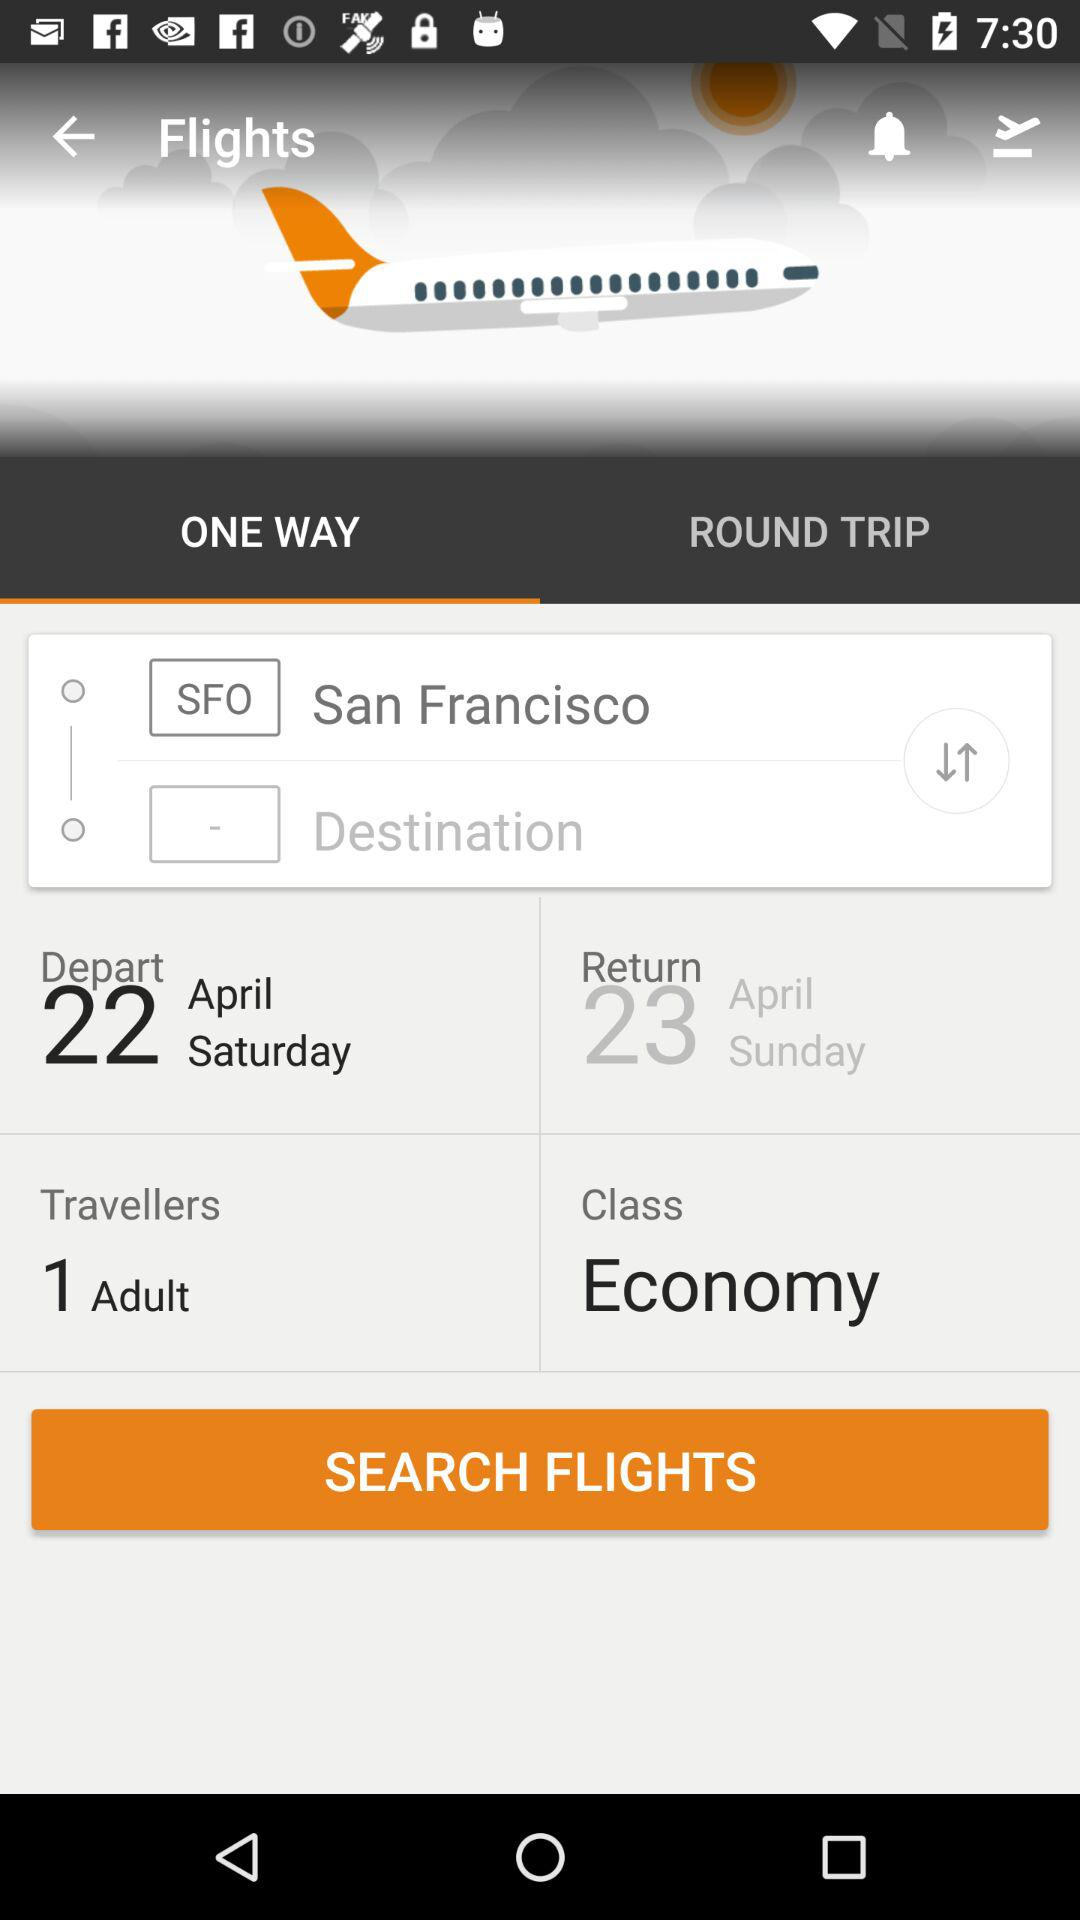Which class is selected for the booking? The selected class is "Economy". 